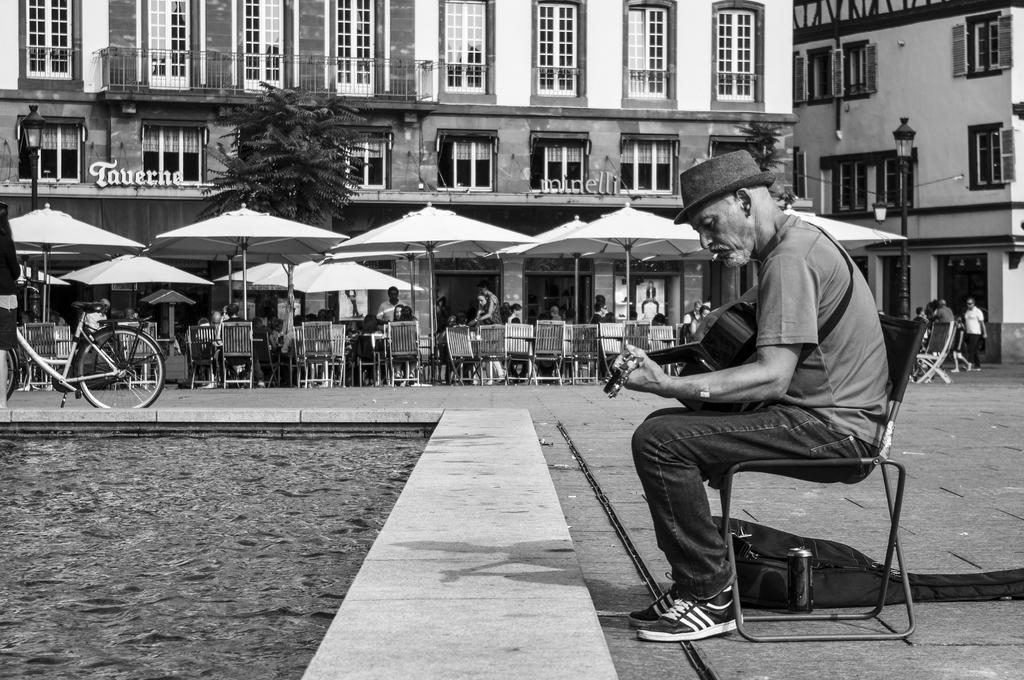How would you summarize this image in a sentence or two? In this picture there is a man who is sitting on the chair, on the right side of the image, he is playing guitar and there are chairs and tables under the umbrellas and there are buildings in the background area of the image, there is a lamp pole on the right side of the image, there is a bicycle on the left side of the image, there is a tree in the image. 